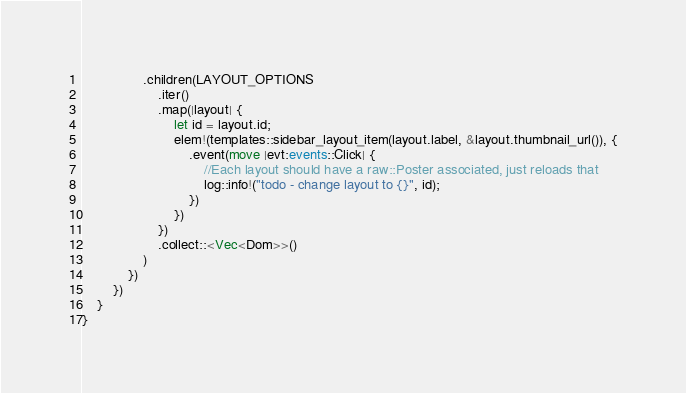<code> <loc_0><loc_0><loc_500><loc_500><_Rust_>                .children(LAYOUT_OPTIONS
                    .iter()
                    .map(|layout| {
                        let id = layout.id;
                        elem!(templates::sidebar_layout_item(layout.label, &layout.thumbnail_url()), {
                            .event(move |evt:events::Click| {
                                //Each layout should have a raw::Poster associated, just reloads that
                                log::info!("todo - change layout to {}", id);
                            })
                        })
                    })
                    .collect::<Vec<Dom>>()
                )
            })
        })
    }
}
</code> 